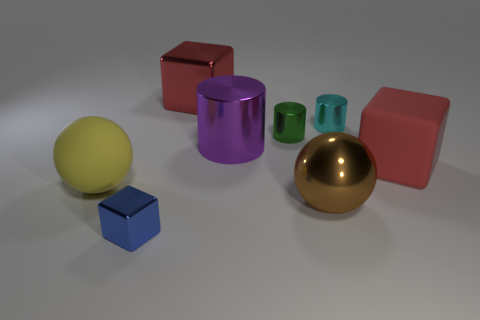Are the blue object and the brown sphere that is to the left of the cyan metal cylinder made of the same material?
Offer a terse response. Yes. There is a large brown ball that is behind the tiny metallic thing in front of the big brown metallic ball; is there a large red metallic block right of it?
Make the answer very short. No. Is there anything else that is the same size as the yellow matte sphere?
Offer a terse response. Yes. What is the color of the large cube that is made of the same material as the large brown object?
Offer a very short reply. Red. What is the size of the thing that is both in front of the large purple object and to the right of the brown object?
Offer a very short reply. Large. Are there fewer small green metal cylinders that are in front of the yellow rubber thing than small metal cubes that are behind the small blue thing?
Ensure brevity in your answer.  No. Is the material of the ball left of the small blue thing the same as the big object in front of the large yellow rubber object?
Provide a succinct answer. No. There is another block that is the same color as the large matte cube; what is its material?
Make the answer very short. Metal. There is a metal thing that is both left of the big purple object and behind the small blue cube; what is its shape?
Give a very brief answer. Cube. There is a ball right of the shiny block behind the blue block; what is its material?
Provide a succinct answer. Metal. 